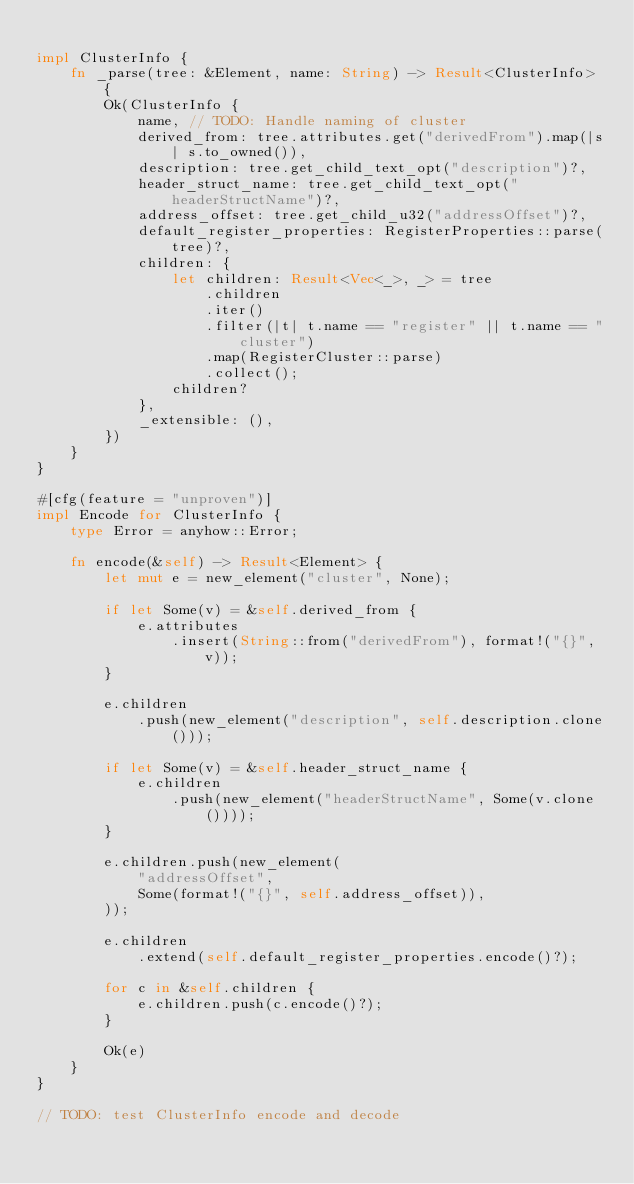<code> <loc_0><loc_0><loc_500><loc_500><_Rust_>
impl ClusterInfo {
    fn _parse(tree: &Element, name: String) -> Result<ClusterInfo> {
        Ok(ClusterInfo {
            name, // TODO: Handle naming of cluster
            derived_from: tree.attributes.get("derivedFrom").map(|s| s.to_owned()),
            description: tree.get_child_text_opt("description")?,
            header_struct_name: tree.get_child_text_opt("headerStructName")?,
            address_offset: tree.get_child_u32("addressOffset")?,
            default_register_properties: RegisterProperties::parse(tree)?,
            children: {
                let children: Result<Vec<_>, _> = tree
                    .children
                    .iter()
                    .filter(|t| t.name == "register" || t.name == "cluster")
                    .map(RegisterCluster::parse)
                    .collect();
                children?
            },
            _extensible: (),
        })
    }
}

#[cfg(feature = "unproven")]
impl Encode for ClusterInfo {
    type Error = anyhow::Error;

    fn encode(&self) -> Result<Element> {
        let mut e = new_element("cluster", None);

        if let Some(v) = &self.derived_from {
            e.attributes
                .insert(String::from("derivedFrom"), format!("{}", v));
        }

        e.children
            .push(new_element("description", self.description.clone()));

        if let Some(v) = &self.header_struct_name {
            e.children
                .push(new_element("headerStructName", Some(v.clone())));
        }

        e.children.push(new_element(
            "addressOffset",
            Some(format!("{}", self.address_offset)),
        ));

        e.children
            .extend(self.default_register_properties.encode()?);

        for c in &self.children {
            e.children.push(c.encode()?);
        }

        Ok(e)
    }
}

// TODO: test ClusterInfo encode and decode
</code> 